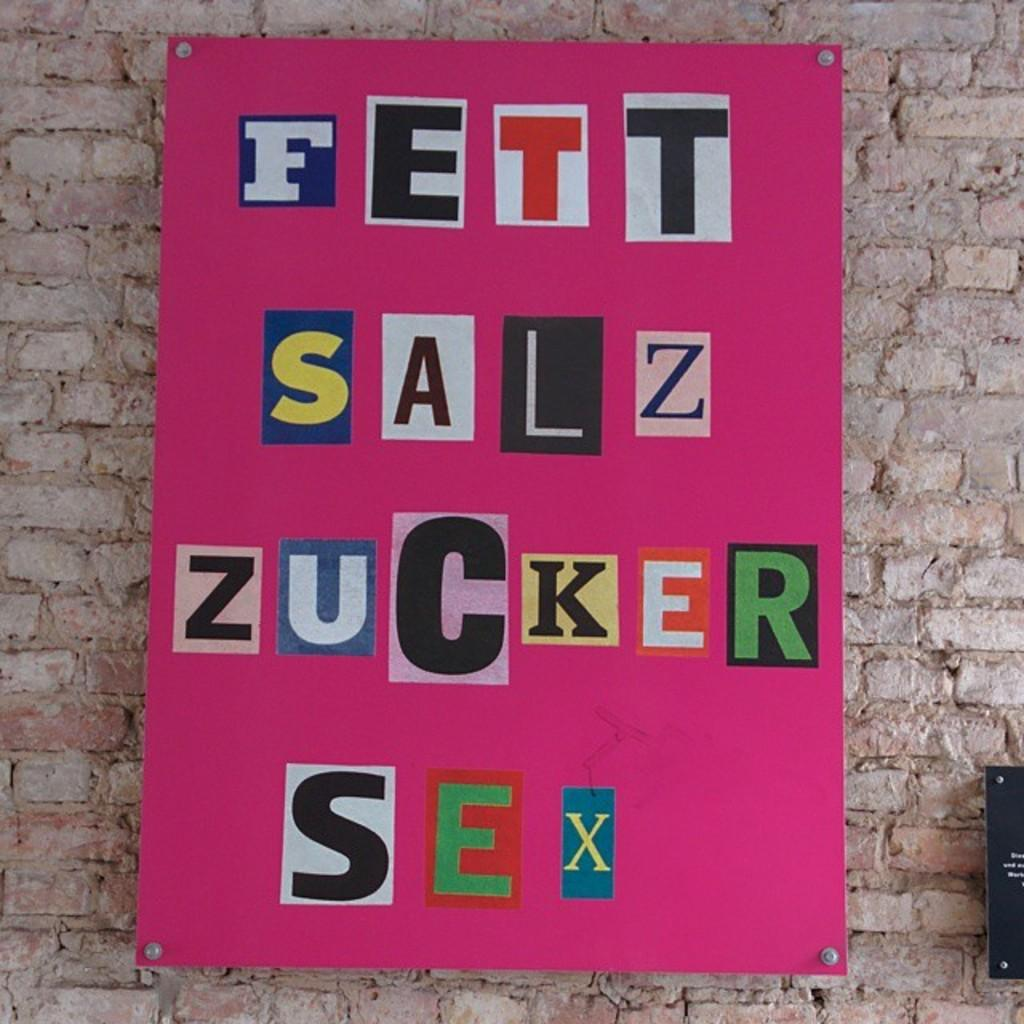<image>
Render a clear and concise summary of the photo. Letters are arranged on a pink poster attached to a brick wall, the first line reading FETT 